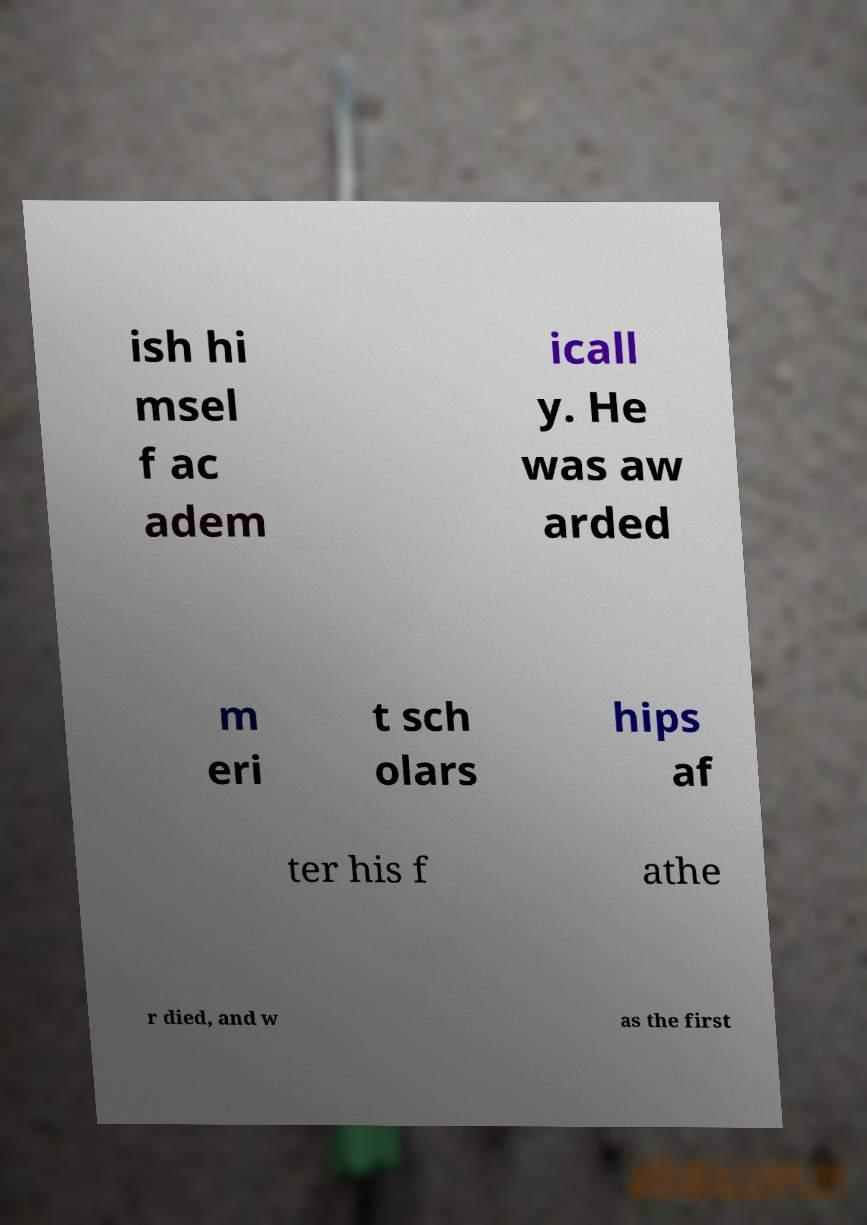Can you read and provide the text displayed in the image?This photo seems to have some interesting text. Can you extract and type it out for me? ish hi msel f ac adem icall y. He was aw arded m eri t sch olars hips af ter his f athe r died, and w as the first 